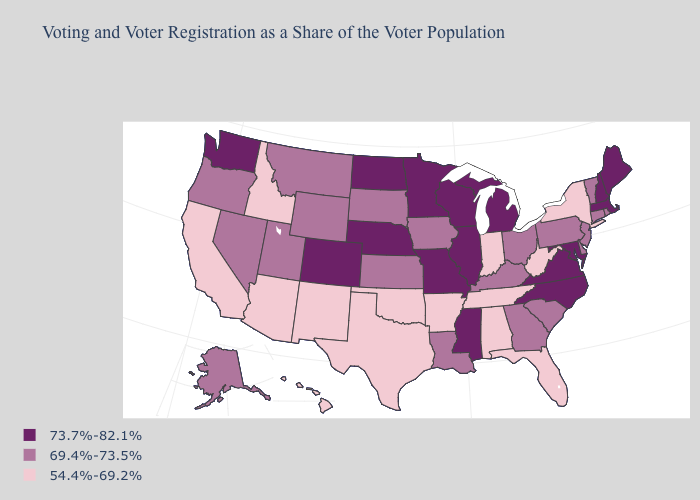Does Massachusetts have the lowest value in the USA?
Quick response, please. No. Name the states that have a value in the range 54.4%-69.2%?
Short answer required. Alabama, Arizona, Arkansas, California, Florida, Hawaii, Idaho, Indiana, New Mexico, New York, Oklahoma, Tennessee, Texas, West Virginia. Does Idaho have a higher value than North Carolina?
Keep it brief. No. What is the value of Ohio?
Short answer required. 69.4%-73.5%. What is the value of Texas?
Quick response, please. 54.4%-69.2%. Is the legend a continuous bar?
Write a very short answer. No. What is the value of Colorado?
Short answer required. 73.7%-82.1%. Does North Carolina have the same value as Arizona?
Write a very short answer. No. Name the states that have a value in the range 54.4%-69.2%?
Be succinct. Alabama, Arizona, Arkansas, California, Florida, Hawaii, Idaho, Indiana, New Mexico, New York, Oklahoma, Tennessee, Texas, West Virginia. What is the value of Delaware?
Concise answer only. 69.4%-73.5%. What is the value of Washington?
Write a very short answer. 73.7%-82.1%. What is the value of New Jersey?
Write a very short answer. 69.4%-73.5%. How many symbols are there in the legend?
Answer briefly. 3. Name the states that have a value in the range 54.4%-69.2%?
Write a very short answer. Alabama, Arizona, Arkansas, California, Florida, Hawaii, Idaho, Indiana, New Mexico, New York, Oklahoma, Tennessee, Texas, West Virginia. 